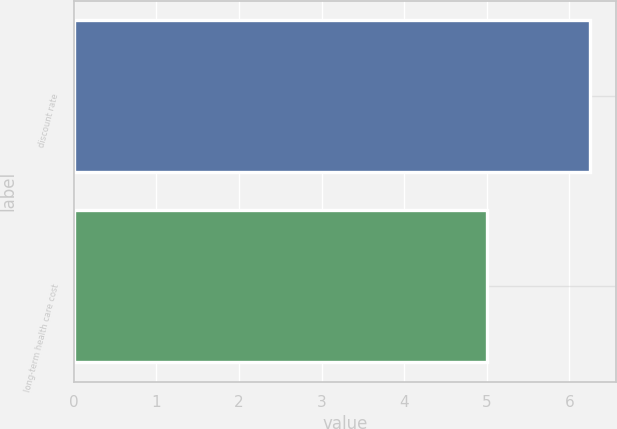<chart> <loc_0><loc_0><loc_500><loc_500><bar_chart><fcel>discount rate<fcel>long-term health care cost<nl><fcel>6.25<fcel>5<nl></chart> 